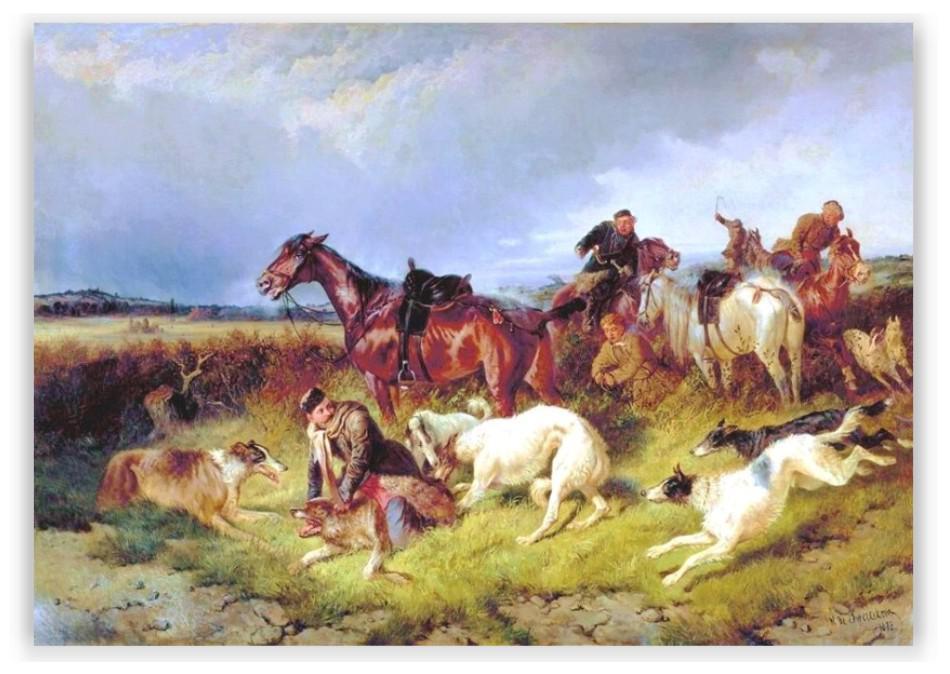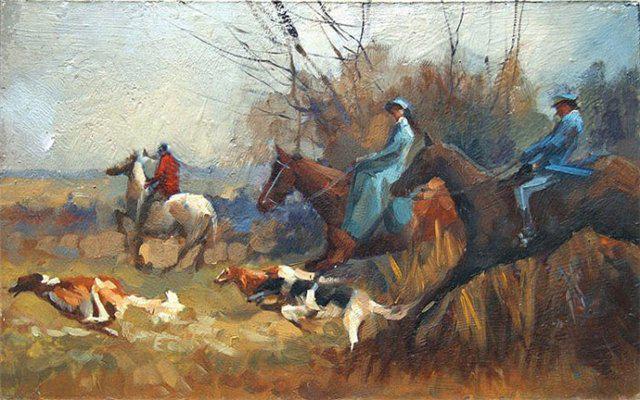The first image is the image on the left, the second image is the image on the right. Analyze the images presented: Is the assertion "An image features a horse rearing up with raised front legs, behind multiple dogs." valid? Answer yes or no. No. 